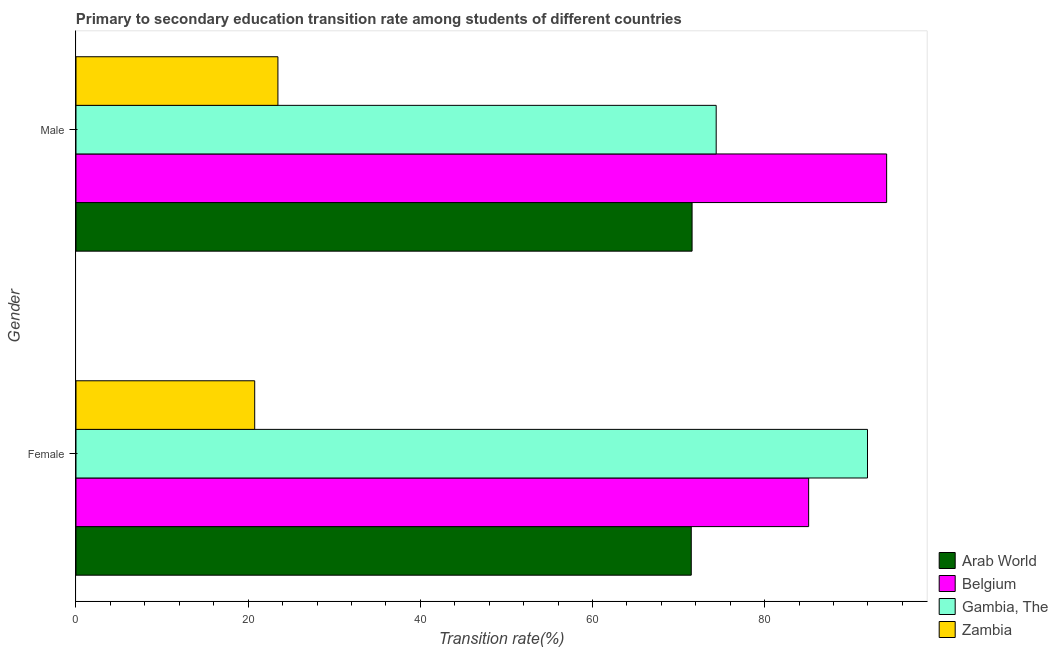How many groups of bars are there?
Ensure brevity in your answer.  2. Are the number of bars per tick equal to the number of legend labels?
Make the answer very short. Yes. Are the number of bars on each tick of the Y-axis equal?
Give a very brief answer. Yes. How many bars are there on the 1st tick from the bottom?
Your response must be concise. 4. What is the label of the 1st group of bars from the top?
Your answer should be very brief. Male. What is the transition rate among male students in Zambia?
Give a very brief answer. 23.46. Across all countries, what is the maximum transition rate among male students?
Ensure brevity in your answer.  94.18. Across all countries, what is the minimum transition rate among male students?
Offer a very short reply. 23.46. In which country was the transition rate among female students maximum?
Provide a succinct answer. Gambia, The. In which country was the transition rate among female students minimum?
Make the answer very short. Zambia. What is the total transition rate among male students in the graph?
Provide a succinct answer. 263.58. What is the difference between the transition rate among male students in Arab World and that in Zambia?
Your answer should be very brief. 48.11. What is the difference between the transition rate among male students in Arab World and the transition rate among female students in Gambia, The?
Your response must be concise. -20.38. What is the average transition rate among female students per country?
Offer a terse response. 67.33. What is the difference between the transition rate among male students and transition rate among female students in Belgium?
Your answer should be compact. 9.06. What is the ratio of the transition rate among female students in Gambia, The to that in Arab World?
Your answer should be very brief. 1.29. What does the 2nd bar from the top in Male represents?
Your response must be concise. Gambia, The. What does the 2nd bar from the bottom in Male represents?
Keep it short and to the point. Belgium. Are all the bars in the graph horizontal?
Provide a short and direct response. Yes. How many countries are there in the graph?
Keep it short and to the point. 4. Are the values on the major ticks of X-axis written in scientific E-notation?
Give a very brief answer. No. Does the graph contain any zero values?
Offer a very short reply. No. How many legend labels are there?
Your response must be concise. 4. What is the title of the graph?
Offer a very short reply. Primary to secondary education transition rate among students of different countries. What is the label or title of the X-axis?
Your response must be concise. Transition rate(%). What is the Transition rate(%) of Arab World in Female?
Offer a very short reply. 71.48. What is the Transition rate(%) in Belgium in Female?
Offer a very short reply. 85.11. What is the Transition rate(%) of Gambia, The in Female?
Make the answer very short. 91.95. What is the Transition rate(%) in Zambia in Female?
Offer a very short reply. 20.76. What is the Transition rate(%) in Arab World in Male?
Your response must be concise. 71.57. What is the Transition rate(%) in Belgium in Male?
Offer a very short reply. 94.18. What is the Transition rate(%) in Gambia, The in Male?
Your answer should be compact. 74.37. What is the Transition rate(%) in Zambia in Male?
Offer a very short reply. 23.46. Across all Gender, what is the maximum Transition rate(%) of Arab World?
Make the answer very short. 71.57. Across all Gender, what is the maximum Transition rate(%) of Belgium?
Provide a succinct answer. 94.18. Across all Gender, what is the maximum Transition rate(%) of Gambia, The?
Your response must be concise. 91.95. Across all Gender, what is the maximum Transition rate(%) in Zambia?
Provide a succinct answer. 23.46. Across all Gender, what is the minimum Transition rate(%) of Arab World?
Ensure brevity in your answer.  71.48. Across all Gender, what is the minimum Transition rate(%) of Belgium?
Offer a terse response. 85.11. Across all Gender, what is the minimum Transition rate(%) of Gambia, The?
Make the answer very short. 74.37. Across all Gender, what is the minimum Transition rate(%) in Zambia?
Make the answer very short. 20.76. What is the total Transition rate(%) of Arab World in the graph?
Offer a terse response. 143.05. What is the total Transition rate(%) of Belgium in the graph?
Give a very brief answer. 179.29. What is the total Transition rate(%) of Gambia, The in the graph?
Your response must be concise. 166.33. What is the total Transition rate(%) of Zambia in the graph?
Your answer should be very brief. 44.22. What is the difference between the Transition rate(%) in Arab World in Female and that in Male?
Ensure brevity in your answer.  -0.09. What is the difference between the Transition rate(%) in Belgium in Female and that in Male?
Make the answer very short. -9.06. What is the difference between the Transition rate(%) of Gambia, The in Female and that in Male?
Your answer should be very brief. 17.58. What is the difference between the Transition rate(%) of Zambia in Female and that in Male?
Your response must be concise. -2.7. What is the difference between the Transition rate(%) of Arab World in Female and the Transition rate(%) of Belgium in Male?
Your response must be concise. -22.7. What is the difference between the Transition rate(%) in Arab World in Female and the Transition rate(%) in Gambia, The in Male?
Your answer should be compact. -2.9. What is the difference between the Transition rate(%) in Arab World in Female and the Transition rate(%) in Zambia in Male?
Your answer should be compact. 48.02. What is the difference between the Transition rate(%) in Belgium in Female and the Transition rate(%) in Gambia, The in Male?
Your answer should be compact. 10.74. What is the difference between the Transition rate(%) of Belgium in Female and the Transition rate(%) of Zambia in Male?
Your response must be concise. 61.66. What is the difference between the Transition rate(%) in Gambia, The in Female and the Transition rate(%) in Zambia in Male?
Offer a terse response. 68.49. What is the average Transition rate(%) in Arab World per Gender?
Offer a terse response. 71.52. What is the average Transition rate(%) in Belgium per Gender?
Provide a succinct answer. 89.64. What is the average Transition rate(%) in Gambia, The per Gender?
Your response must be concise. 83.16. What is the average Transition rate(%) in Zambia per Gender?
Your response must be concise. 22.11. What is the difference between the Transition rate(%) of Arab World and Transition rate(%) of Belgium in Female?
Your response must be concise. -13.64. What is the difference between the Transition rate(%) in Arab World and Transition rate(%) in Gambia, The in Female?
Provide a succinct answer. -20.47. What is the difference between the Transition rate(%) of Arab World and Transition rate(%) of Zambia in Female?
Provide a short and direct response. 50.72. What is the difference between the Transition rate(%) of Belgium and Transition rate(%) of Gambia, The in Female?
Keep it short and to the point. -6.84. What is the difference between the Transition rate(%) in Belgium and Transition rate(%) in Zambia in Female?
Ensure brevity in your answer.  64.35. What is the difference between the Transition rate(%) in Gambia, The and Transition rate(%) in Zambia in Female?
Provide a short and direct response. 71.19. What is the difference between the Transition rate(%) in Arab World and Transition rate(%) in Belgium in Male?
Offer a terse response. -22.6. What is the difference between the Transition rate(%) in Arab World and Transition rate(%) in Gambia, The in Male?
Keep it short and to the point. -2.8. What is the difference between the Transition rate(%) of Arab World and Transition rate(%) of Zambia in Male?
Keep it short and to the point. 48.11. What is the difference between the Transition rate(%) of Belgium and Transition rate(%) of Gambia, The in Male?
Offer a very short reply. 19.8. What is the difference between the Transition rate(%) in Belgium and Transition rate(%) in Zambia in Male?
Provide a succinct answer. 70.72. What is the difference between the Transition rate(%) in Gambia, The and Transition rate(%) in Zambia in Male?
Your answer should be compact. 50.91. What is the ratio of the Transition rate(%) of Belgium in Female to that in Male?
Provide a succinct answer. 0.9. What is the ratio of the Transition rate(%) in Gambia, The in Female to that in Male?
Your answer should be compact. 1.24. What is the ratio of the Transition rate(%) of Zambia in Female to that in Male?
Provide a succinct answer. 0.89. What is the difference between the highest and the second highest Transition rate(%) in Arab World?
Your response must be concise. 0.09. What is the difference between the highest and the second highest Transition rate(%) in Belgium?
Keep it short and to the point. 9.06. What is the difference between the highest and the second highest Transition rate(%) of Gambia, The?
Offer a terse response. 17.58. What is the difference between the highest and the second highest Transition rate(%) of Zambia?
Your answer should be compact. 2.7. What is the difference between the highest and the lowest Transition rate(%) in Arab World?
Give a very brief answer. 0.09. What is the difference between the highest and the lowest Transition rate(%) of Belgium?
Offer a very short reply. 9.06. What is the difference between the highest and the lowest Transition rate(%) in Gambia, The?
Ensure brevity in your answer.  17.58. What is the difference between the highest and the lowest Transition rate(%) of Zambia?
Offer a terse response. 2.7. 